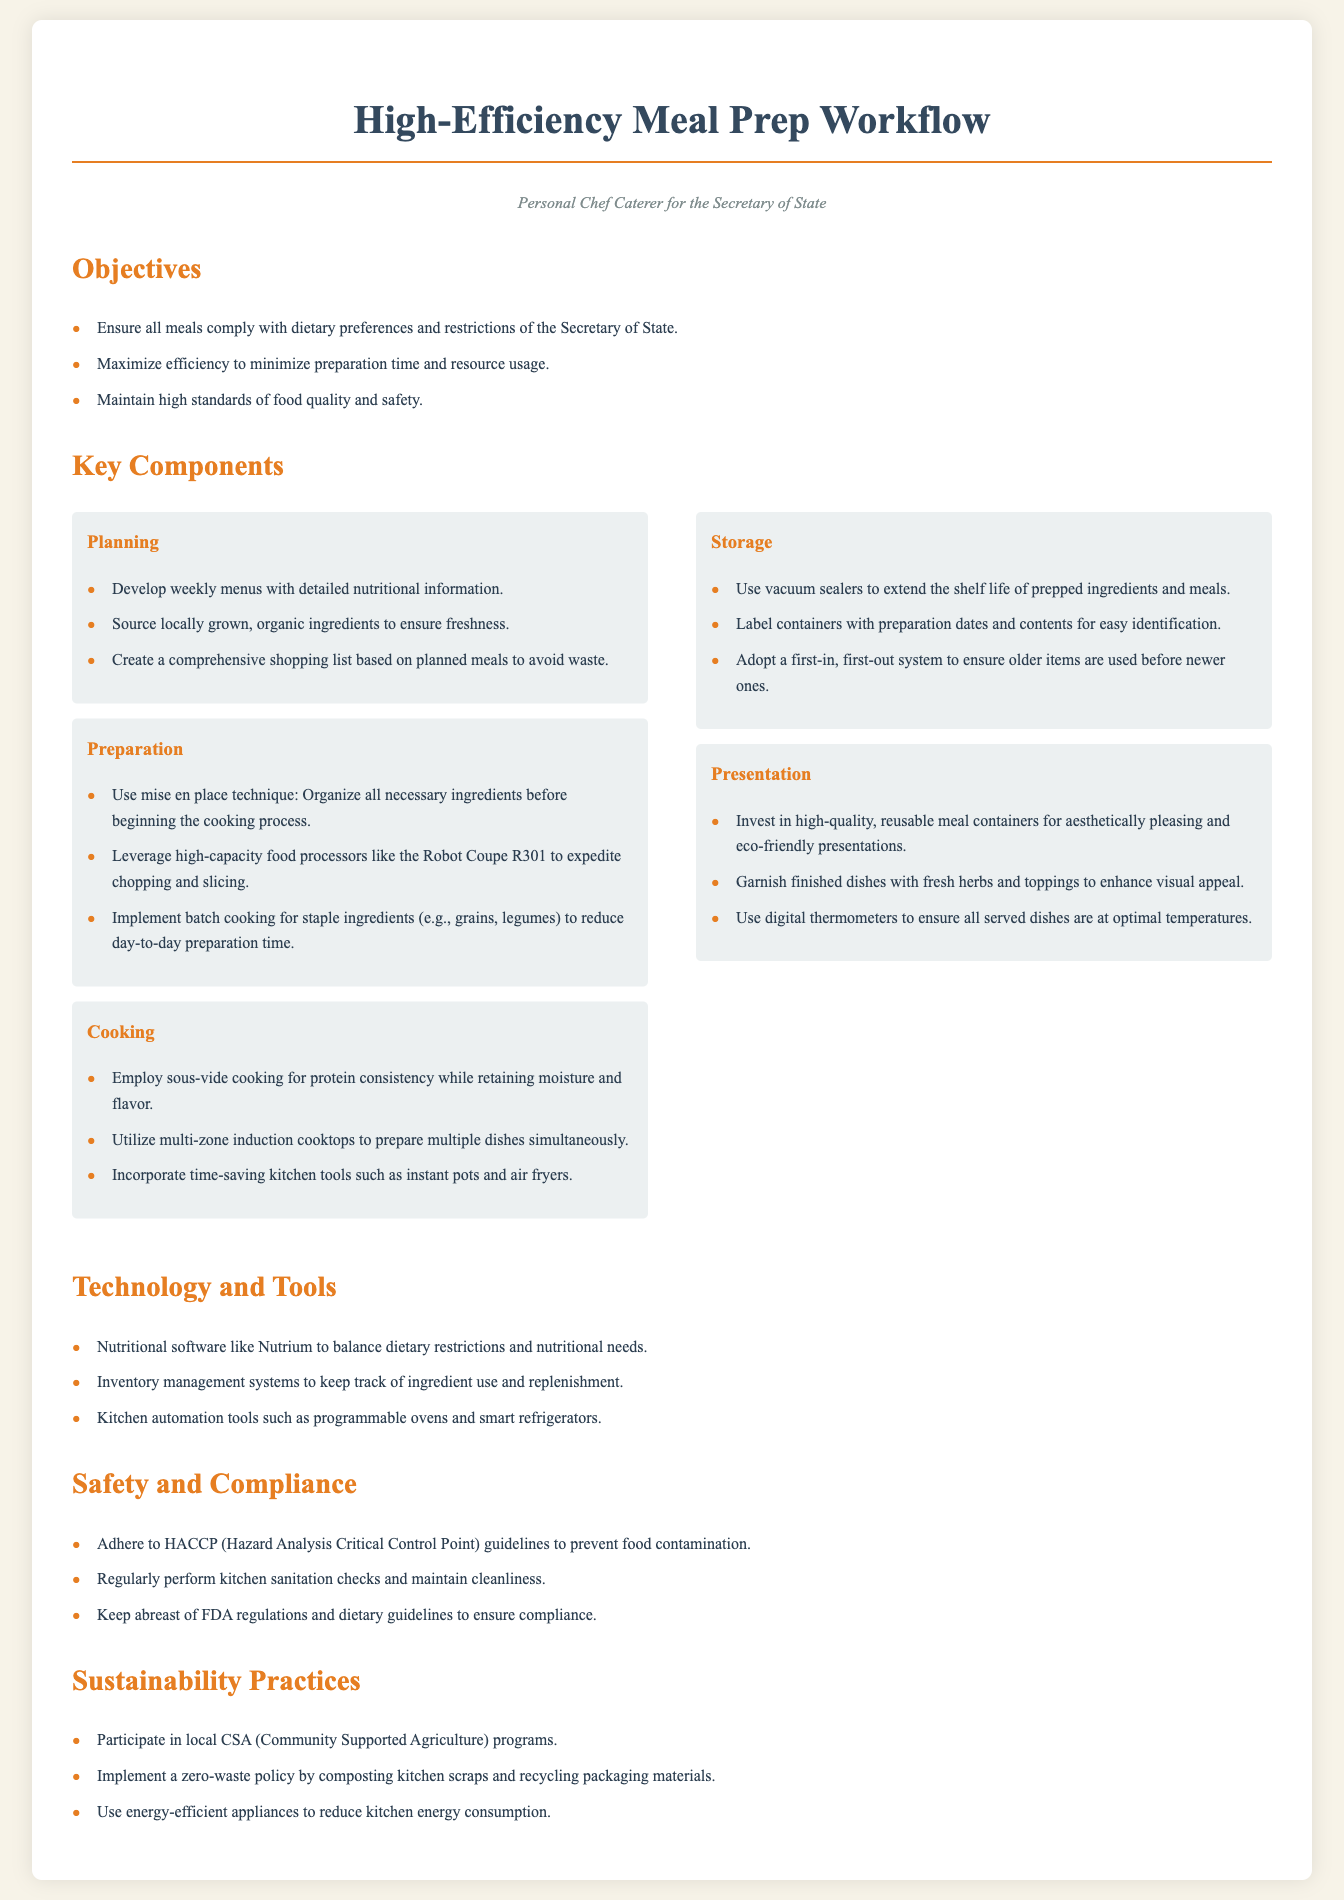what is the primary objective of the meal prep workflow? The primary objective is to ensure all meals comply with dietary preferences and restrictions of the Secretary of State.
Answer: comply with dietary preferences and restrictions how many key components are there in the document? The document outlines five key components of the meal prep workflow.
Answer: five which technique is used for organizing ingredients before cooking? The mise en place technique is used for organizing ingredients before cooking.
Answer: mise en place what type of cooking is employed to retain moisture and flavor in protein? Sous-vide cooking is employed to retain moisture and flavor in protein.
Answer: sous-vide cooking what software is mentioned for balancing dietary restrictions? Nutritional software like Nutrium is mentioned for balancing dietary restrictions.
Answer: Nutrium how often should kitchen sanitation checks be performed? The document does not specify a frequency, but it indicates that regular checks are necessary.
Answer: regularly what is the purpose of using a first-in, first-out system in storage? The purpose is to ensure older items are used before newer ones.
Answer: to ensure older items are used before newer ones which sustainability practice involves composting kitchen scraps? Implementing a zero-waste policy involves composting kitchen scraps.
Answer: zero-waste policy what should be labeled on storage containers? Containers should be labeled with preparation dates and contents.
Answer: preparation dates and contents 